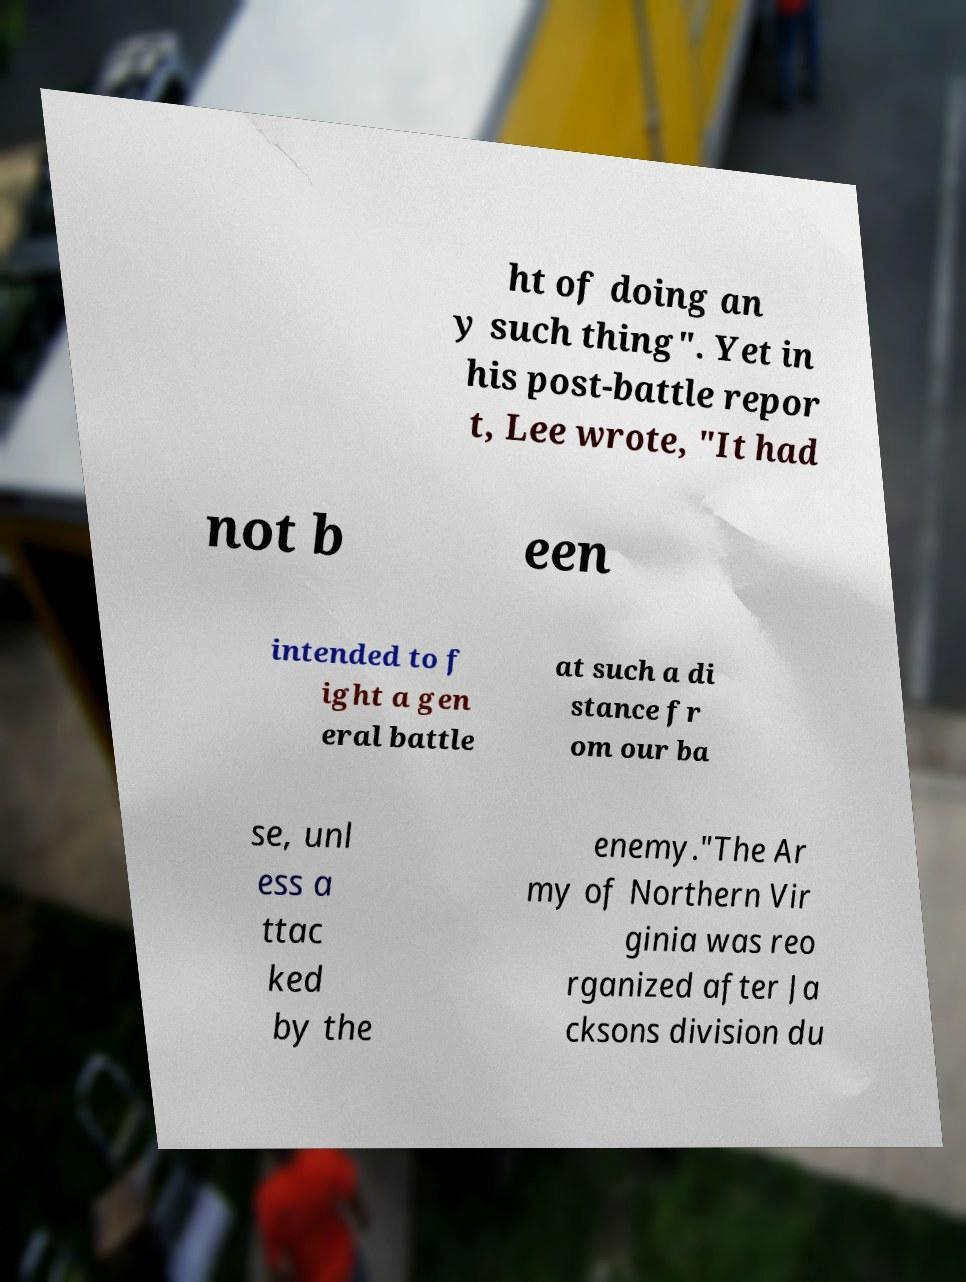Please read and relay the text visible in this image. What does it say? ht of doing an y such thing". Yet in his post-battle repor t, Lee wrote, "It had not b een intended to f ight a gen eral battle at such a di stance fr om our ba se, unl ess a ttac ked by the enemy."The Ar my of Northern Vir ginia was reo rganized after Ja cksons division du 